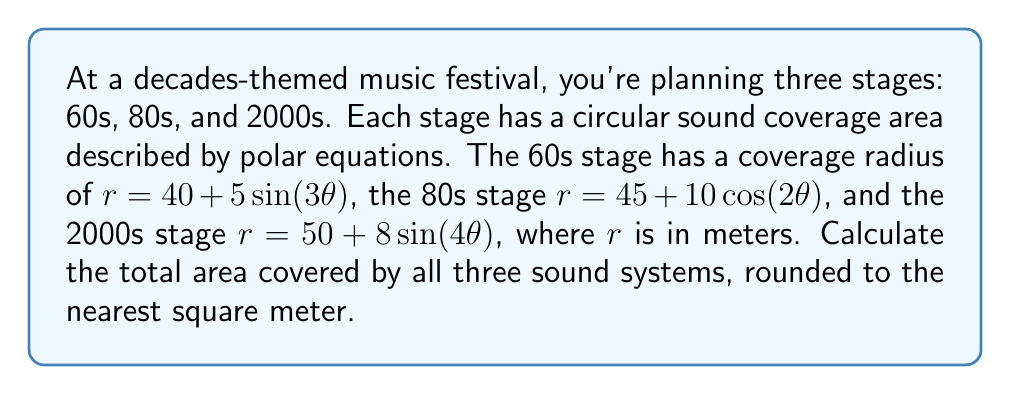Show me your answer to this math problem. To solve this problem, we need to calculate the area of each stage's coverage and then sum them up. The area of a region in polar coordinates is given by the formula:

$$ A = \frac{1}{2} \int_{0}^{2\pi} r^2(\theta) d\theta $$

Let's calculate the area for each stage:

1. 60s stage: $r = 40 + 5\sin(3\theta)$
   $$ A_{60s} = \frac{1}{2} \int_{0}^{2\pi} (40 + 5\sin(3\theta))^2 d\theta $$
   $$ = \frac{1}{2} \int_{0}^{2\pi} (1600 + 400\sin(3\theta) + 25\sin^2(3\theta)) d\theta $$
   $$ = \frac{1}{2} [1600\theta + \frac{400}{3}\cos(3\theta) + \frac{25}{2}\theta - \frac{25}{12}\sin(6\theta)]_{0}^{2\pi} $$
   $$ = \frac{1}{2} (3200\pi + 25\pi) = 1612.5\pi \approx 5066.55 \text{ m}^2 $$

2. 80s stage: $r = 45 + 10\cos(2\theta)$
   $$ A_{80s} = \frac{1}{2} \int_{0}^{2\pi} (45 + 10\cos(2\theta))^2 d\theta $$
   $$ = \frac{1}{2} \int_{0}^{2\pi} (2025 + 900\cos(2\theta) + 100\cos^2(2\theta)) d\theta $$
   $$ = \frac{1}{2} [2025\theta - \frac{900}{2}\sin(2\theta) + 50\theta + \frac{25}{2}\sin(4\theta)]_{0}^{2\pi} $$
   $$ = \frac{1}{2} (4050\pi + 100\pi) = 2075\pi \approx 6518.58 \text{ m}^2 $$

3. 2000s stage: $r = 50 + 8\sin(4\theta)$
   $$ A_{2000s} = \frac{1}{2} \int_{0}^{2\pi} (50 + 8\sin(4\theta))^2 d\theta $$
   $$ = \frac{1}{2} \int_{0}^{2\pi} (2500 + 800\sin(4\theta) + 64\sin^2(4\theta)) d\theta $$
   $$ = \frac{1}{2} [2500\theta + \frac{800}{4}\cos(4\theta) + 32\theta - \frac{32}{8}\sin(8\theta)]_{0}^{2\pi} $$
   $$ = \frac{1}{2} (5000\pi + 64\pi) = 2532\pi \approx 7952.16 \text{ m}^2 $$

The total area is the sum of all three:
$$ A_{total} = A_{60s} + A_{80s} + A_{2000s} $$
$$ = 1612.5\pi + 2075\pi + 2532\pi = 6219.5\pi \approx 19537.29 \text{ m}^2 $$
Answer: 19537 square meters 